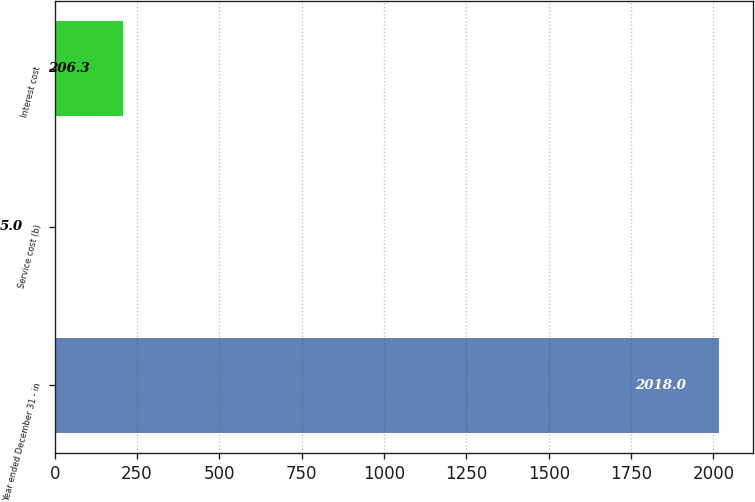<chart> <loc_0><loc_0><loc_500><loc_500><bar_chart><fcel>Year ended December 31 - in<fcel>Service cost (b)<fcel>Interest cost<nl><fcel>2018<fcel>5<fcel>206.3<nl></chart> 